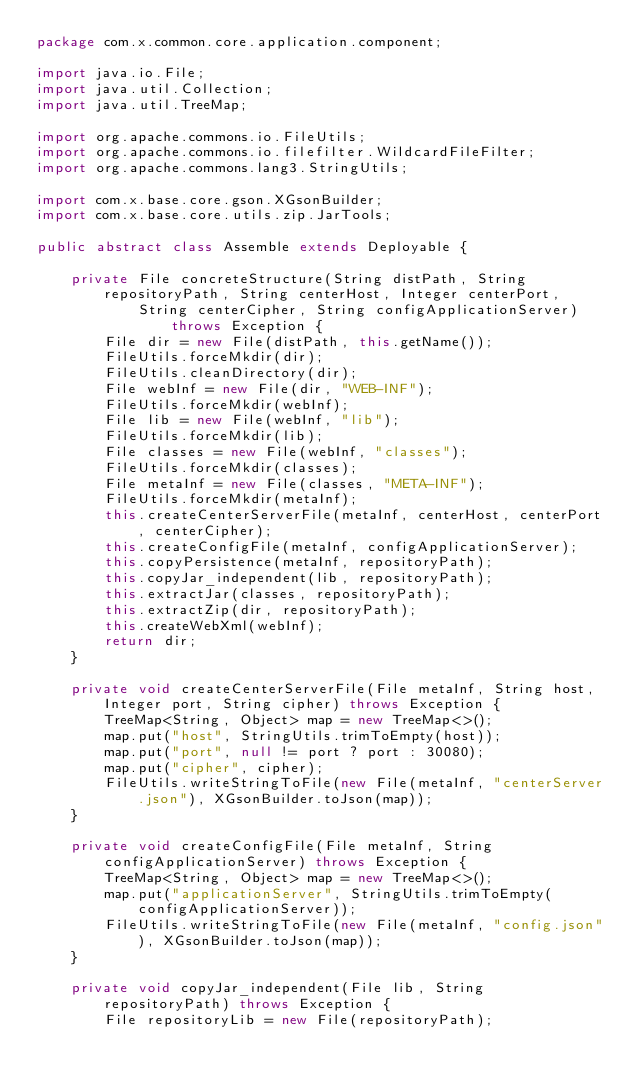Convert code to text. <code><loc_0><loc_0><loc_500><loc_500><_Java_>package com.x.common.core.application.component;

import java.io.File;
import java.util.Collection;
import java.util.TreeMap;

import org.apache.commons.io.FileUtils;
import org.apache.commons.io.filefilter.WildcardFileFilter;
import org.apache.commons.lang3.StringUtils;

import com.x.base.core.gson.XGsonBuilder;
import com.x.base.core.utils.zip.JarTools;

public abstract class Assemble extends Deployable {

	private File concreteStructure(String distPath, String repositoryPath, String centerHost, Integer centerPort,
			String centerCipher, String configApplicationServer) throws Exception {
		File dir = new File(distPath, this.getName());
		FileUtils.forceMkdir(dir);
		FileUtils.cleanDirectory(dir);
		File webInf = new File(dir, "WEB-INF");
		FileUtils.forceMkdir(webInf);
		File lib = new File(webInf, "lib");
		FileUtils.forceMkdir(lib);
		File classes = new File(webInf, "classes");
		FileUtils.forceMkdir(classes);
		File metaInf = new File(classes, "META-INF");
		FileUtils.forceMkdir(metaInf);
		this.createCenterServerFile(metaInf, centerHost, centerPort, centerCipher);
		this.createConfigFile(metaInf, configApplicationServer);
		this.copyPersistence(metaInf, repositoryPath);
		this.copyJar_independent(lib, repositoryPath);
		this.extractJar(classes, repositoryPath);
		this.extractZip(dir, repositoryPath);
		this.createWebXml(webInf);
		return dir;
	}

	private void createCenterServerFile(File metaInf, String host, Integer port, String cipher) throws Exception {
		TreeMap<String, Object> map = new TreeMap<>();
		map.put("host", StringUtils.trimToEmpty(host));
		map.put("port", null != port ? port : 30080);
		map.put("cipher", cipher);
		FileUtils.writeStringToFile(new File(metaInf, "centerServer.json"), XGsonBuilder.toJson(map));
	}

	private void createConfigFile(File metaInf, String configApplicationServer) throws Exception {
		TreeMap<String, Object> map = new TreeMap<>();
		map.put("applicationServer", StringUtils.trimToEmpty(configApplicationServer));
		FileUtils.writeStringToFile(new File(metaInf, "config.json"), XGsonBuilder.toJson(map));
	}

	private void copyJar_independent(File lib, String repositoryPath) throws Exception {
		File repositoryLib = new File(repositoryPath);</code> 